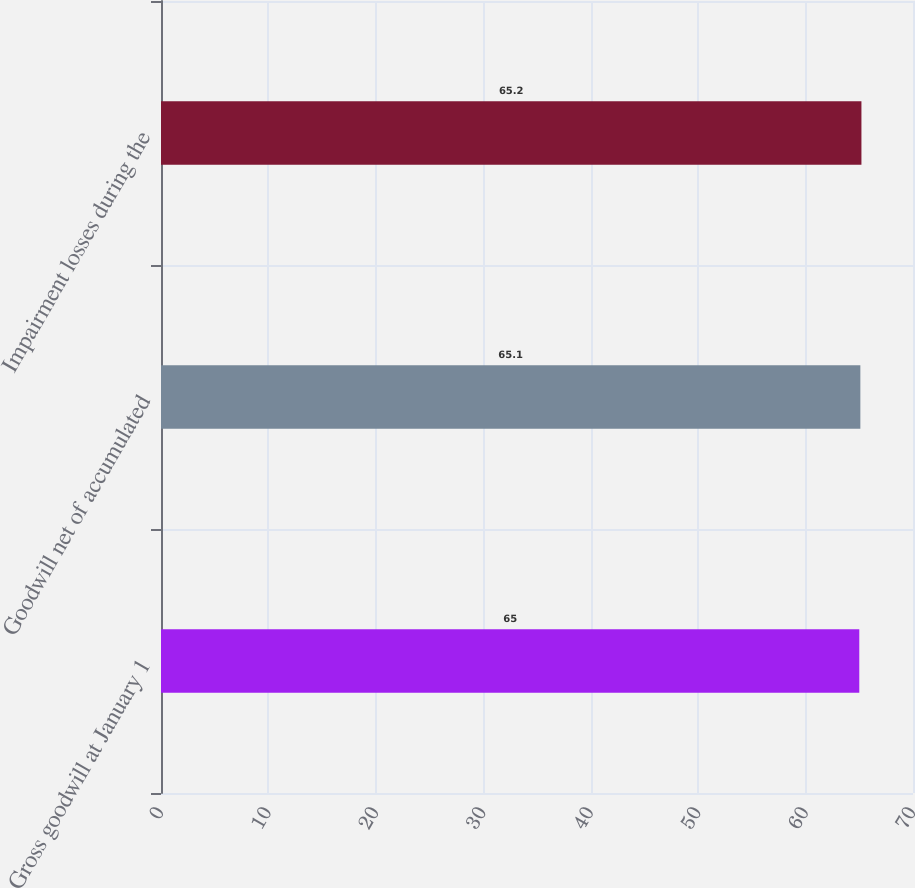Convert chart. <chart><loc_0><loc_0><loc_500><loc_500><bar_chart><fcel>Gross goodwill at January 1<fcel>Goodwill net of accumulated<fcel>Impairment losses during the<nl><fcel>65<fcel>65.1<fcel>65.2<nl></chart> 